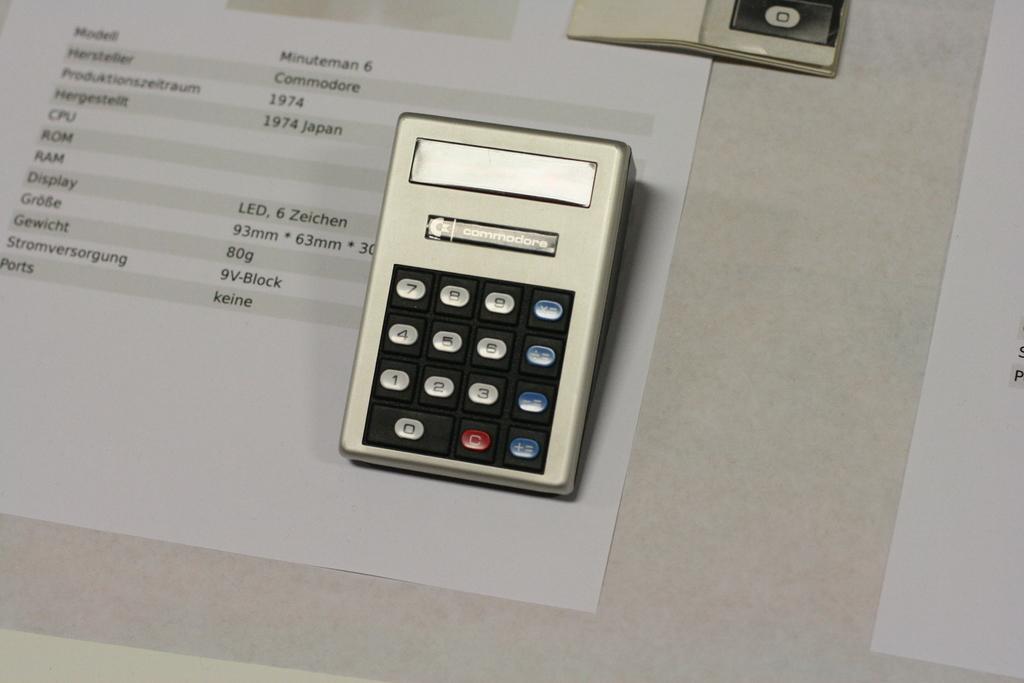What year is on the form?
Your answer should be very brief. 1974. What country is on the form?
Provide a short and direct response. Japan. 